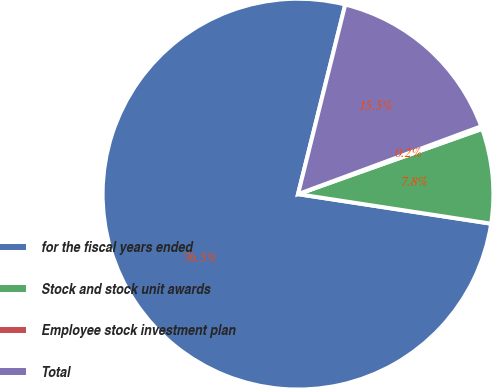Convert chart. <chart><loc_0><loc_0><loc_500><loc_500><pie_chart><fcel>for the fiscal years ended<fcel>Stock and stock unit awards<fcel>Employee stock investment plan<fcel>Total<nl><fcel>76.47%<fcel>7.84%<fcel>0.22%<fcel>15.47%<nl></chart> 